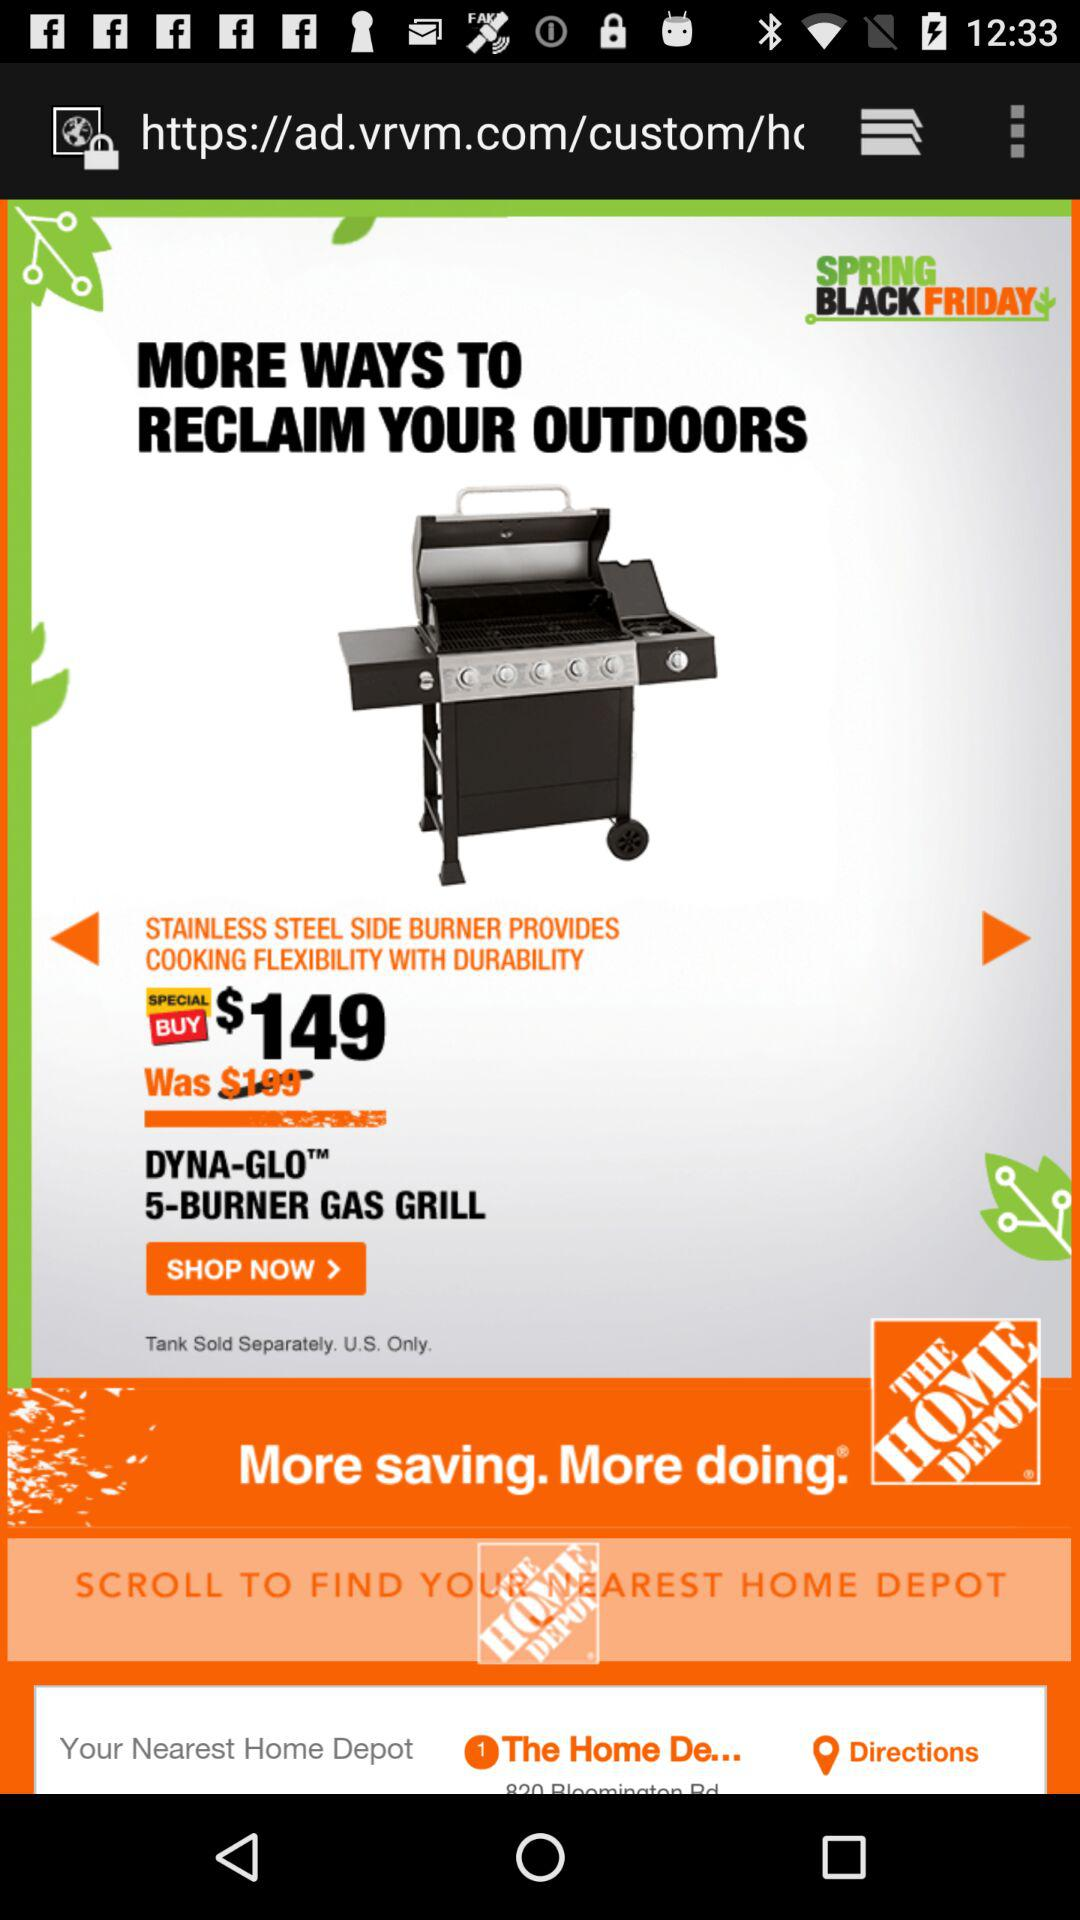What is the price of "STAINLESS STEEL SIDE BURNER"? The price is $149. 